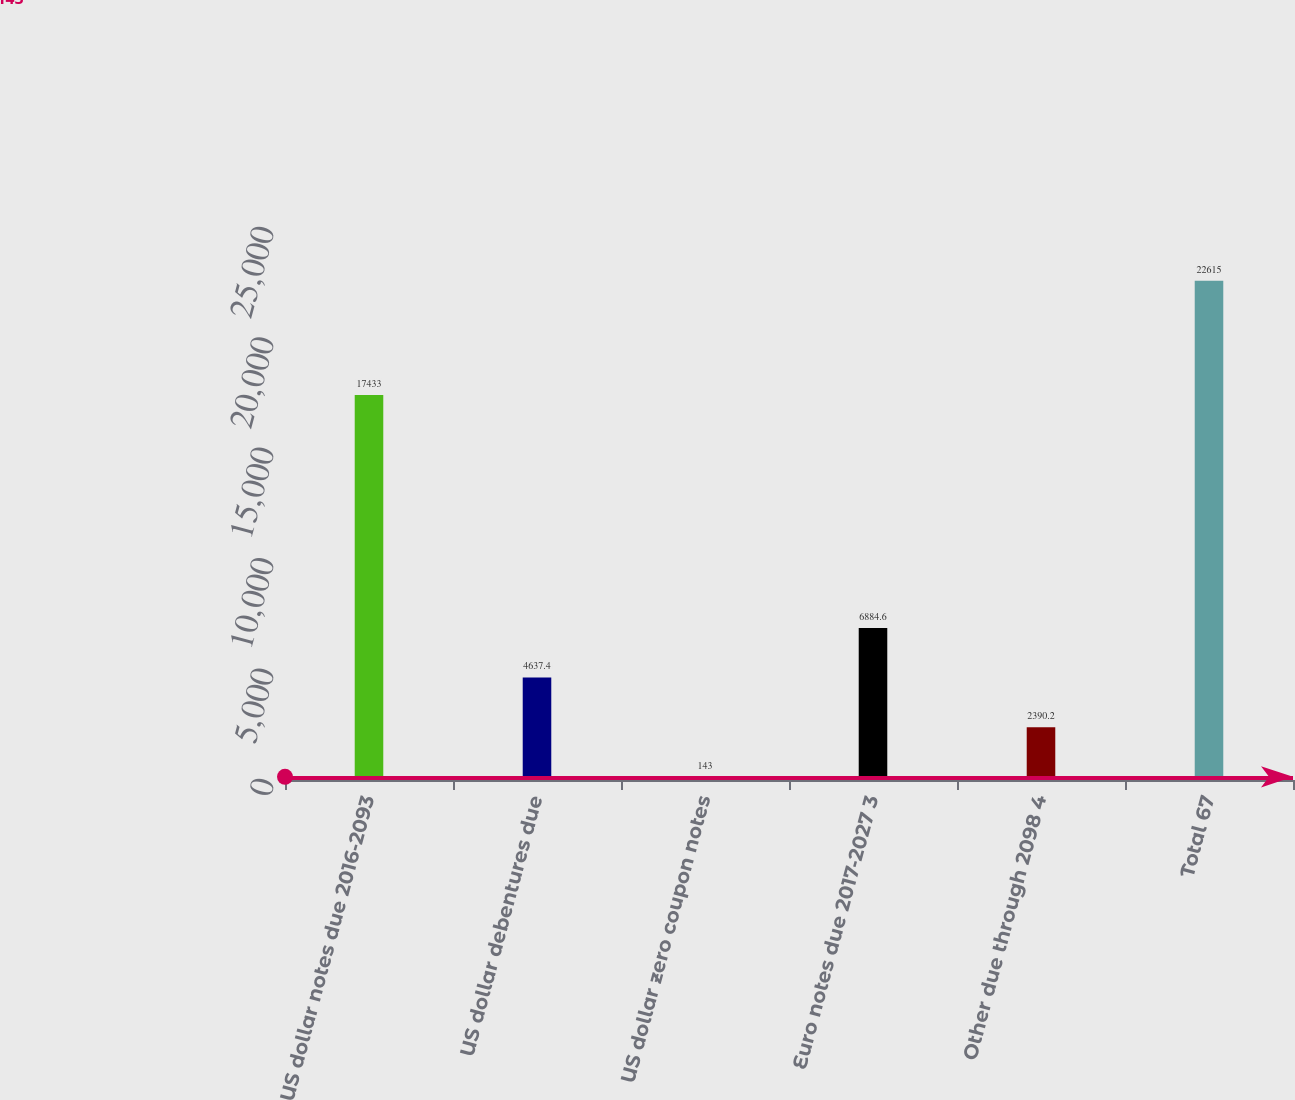Convert chart to OTSL. <chart><loc_0><loc_0><loc_500><loc_500><bar_chart><fcel>US dollar notes due 2016-2093<fcel>US dollar debentures due<fcel>US dollar zero coupon notes<fcel>Euro notes due 2017-2027 3<fcel>Other due through 2098 4<fcel>Total 67<nl><fcel>17433<fcel>4637.4<fcel>143<fcel>6884.6<fcel>2390.2<fcel>22615<nl></chart> 